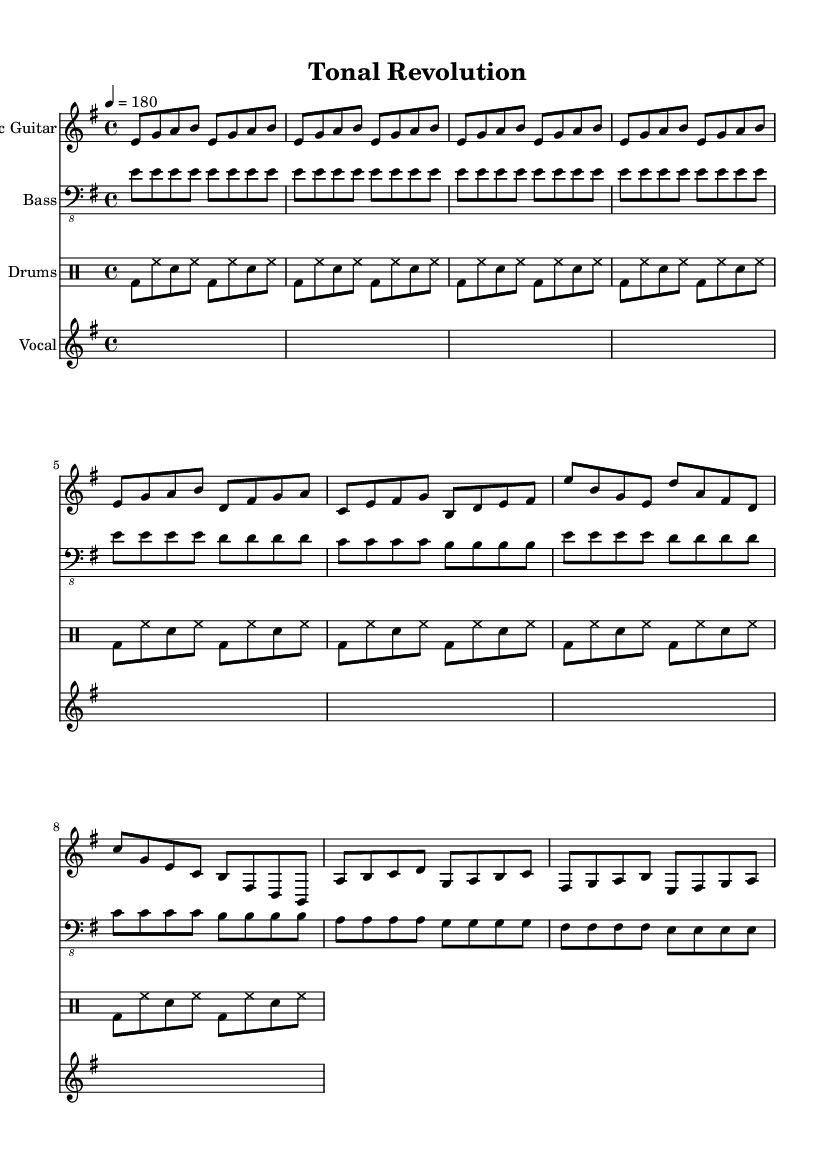What is the key signature of this music? The key signature is E minor, which is indicated by one sharp (F#). The presence of a single sharp suggests that this is the relative minor of G major, confirming that the key is E minor.
Answer: E minor What is the time signature of this music? The time signature is 4/4, which can be identified by the notation at the beginning of the score. It indicates that there are four beats per measure and that the quarter note receives one beat.
Answer: 4/4 What is the tempo marking for this piece? The tempo marking is indicated as "4 = 180," which means there are 180 quarter note beats per minute, providing a fast pace for punk music that is typically characterized by high energy.
Answer: 180 What is the main instrument used for melody? The main instrument used for melody is the electric guitar, as denoted in the score where it is clearly labeled with its own staff.
Answer: Electric Guitar How many beats are in a measure? There are four beats in a measure, as indicated by the 4/4 time signature. This means each measure of music is comprised of four quarter note beats.
Answer: Four What is the primary musical structure used in the piece? The primary musical structure consists of an intro, verse, chorus, and bridge, which are common elements in punk music that help to create a dynamic and engaging song layout.
Answer: Intro, Verse, Chorus, Bridge How does the bass guitar support the song's rhythm? The bass guitar supports the rhythm by mimicking a simple repetitive pattern that adds depth and foundation to the song. Its consistent quarter note rhythm underpins the energetic feel typical of punk music.
Answer: Repetitive pattern 